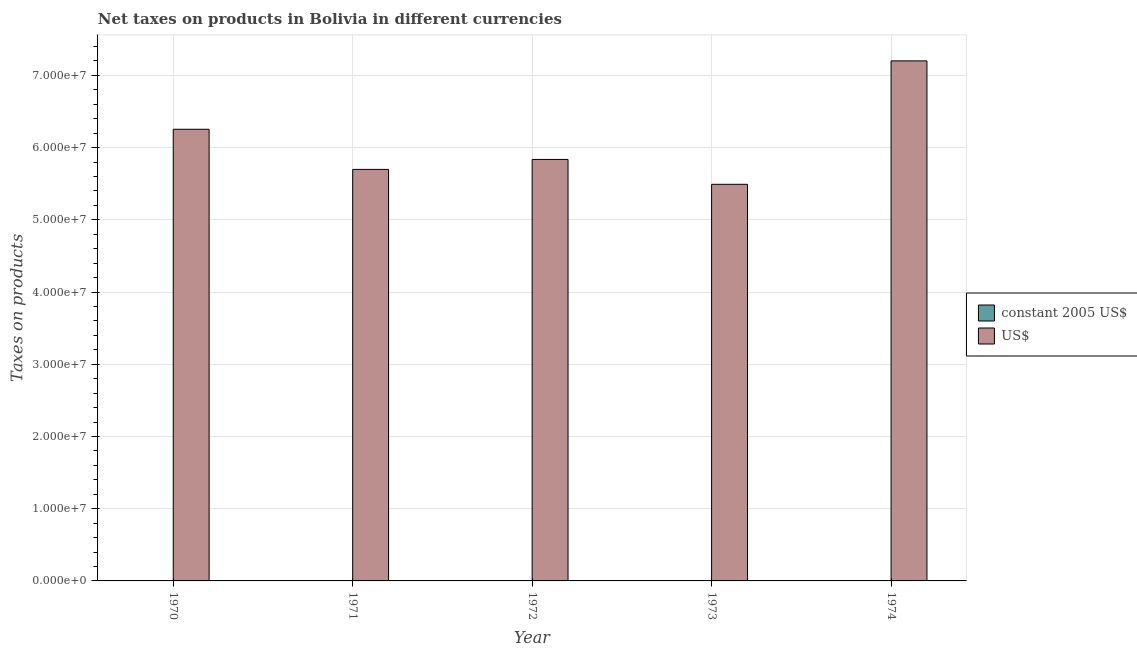How many different coloured bars are there?
Provide a succinct answer. 2. Are the number of bars on each tick of the X-axis equal?
Provide a succinct answer. Yes. What is the net taxes in constant 2005 us$ in 1974?
Offer a very short reply. 1441. Across all years, what is the maximum net taxes in constant 2005 us$?
Give a very brief answer. 1441. Across all years, what is the minimum net taxes in us$?
Offer a very short reply. 5.49e+07. In which year was the net taxes in constant 2005 us$ maximum?
Provide a short and direct response. 1974. In which year was the net taxes in us$ minimum?
Give a very brief answer. 1973. What is the total net taxes in constant 2005 us$ in the graph?
Make the answer very short. 4736. What is the difference between the net taxes in constant 2005 us$ in 1971 and that in 1972?
Provide a short and direct response. -99. What is the difference between the net taxes in us$ in 1971 and the net taxes in constant 2005 us$ in 1972?
Offer a very short reply. -1.38e+06. What is the average net taxes in us$ per year?
Keep it short and to the point. 6.10e+07. In how many years, is the net taxes in constant 2005 us$ greater than 12000000 units?
Your answer should be very brief. 0. What is the ratio of the net taxes in constant 2005 us$ in 1973 to that in 1974?
Ensure brevity in your answer.  0.76. Is the difference between the net taxes in constant 2005 us$ in 1970 and 1973 greater than the difference between the net taxes in us$ in 1970 and 1973?
Provide a succinct answer. No. What is the difference between the highest and the second highest net taxes in us$?
Provide a succinct answer. 9.47e+06. What is the difference between the highest and the lowest net taxes in us$?
Provide a short and direct response. 1.71e+07. In how many years, is the net taxes in us$ greater than the average net taxes in us$ taken over all years?
Keep it short and to the point. 2. Is the sum of the net taxes in constant 2005 us$ in 1973 and 1974 greater than the maximum net taxes in us$ across all years?
Offer a terse response. Yes. What does the 2nd bar from the left in 1971 represents?
Make the answer very short. US$. What does the 1st bar from the right in 1974 represents?
Provide a short and direct response. US$. How many bars are there?
Make the answer very short. 10. How many years are there in the graph?
Offer a very short reply. 5. What is the difference between two consecutive major ticks on the Y-axis?
Provide a short and direct response. 1.00e+07. Does the graph contain any zero values?
Provide a short and direct response. No. Does the graph contain grids?
Your response must be concise. Yes. Where does the legend appear in the graph?
Give a very brief answer. Center right. What is the title of the graph?
Your response must be concise. Net taxes on products in Bolivia in different currencies. Does "US$" appear as one of the legend labels in the graph?
Offer a terse response. Yes. What is the label or title of the Y-axis?
Keep it short and to the point. Taxes on products. What is the Taxes on products in constant 2005 US$ in 1970?
Your answer should be very brief. 743. What is the Taxes on products in US$ in 1970?
Make the answer very short. 6.25e+07. What is the Taxes on products of constant 2005 US$ in 1971?
Your answer should be compact. 677. What is the Taxes on products in US$ in 1971?
Provide a succinct answer. 5.70e+07. What is the Taxes on products of constant 2005 US$ in 1972?
Ensure brevity in your answer.  776. What is the Taxes on products of US$ in 1972?
Ensure brevity in your answer.  5.84e+07. What is the Taxes on products in constant 2005 US$ in 1973?
Give a very brief answer. 1099. What is the Taxes on products in US$ in 1973?
Your answer should be compact. 5.49e+07. What is the Taxes on products in constant 2005 US$ in 1974?
Provide a succinct answer. 1441. What is the Taxes on products of US$ in 1974?
Your response must be concise. 7.20e+07. Across all years, what is the maximum Taxes on products of constant 2005 US$?
Keep it short and to the point. 1441. Across all years, what is the maximum Taxes on products in US$?
Provide a succinct answer. 7.20e+07. Across all years, what is the minimum Taxes on products of constant 2005 US$?
Provide a short and direct response. 677. Across all years, what is the minimum Taxes on products in US$?
Provide a succinct answer. 5.49e+07. What is the total Taxes on products of constant 2005 US$ in the graph?
Keep it short and to the point. 4736. What is the total Taxes on products in US$ in the graph?
Ensure brevity in your answer.  3.05e+08. What is the difference between the Taxes on products in US$ in 1970 and that in 1971?
Ensure brevity in your answer.  5.56e+06. What is the difference between the Taxes on products in constant 2005 US$ in 1970 and that in 1972?
Offer a terse response. -33. What is the difference between the Taxes on products in US$ in 1970 and that in 1972?
Make the answer very short. 4.17e+06. What is the difference between the Taxes on products in constant 2005 US$ in 1970 and that in 1973?
Offer a terse response. -356. What is the difference between the Taxes on products in US$ in 1970 and that in 1973?
Your answer should be very brief. 7.62e+06. What is the difference between the Taxes on products of constant 2005 US$ in 1970 and that in 1974?
Offer a terse response. -698. What is the difference between the Taxes on products in US$ in 1970 and that in 1974?
Give a very brief answer. -9.47e+06. What is the difference between the Taxes on products in constant 2005 US$ in 1971 and that in 1972?
Your response must be concise. -99. What is the difference between the Taxes on products of US$ in 1971 and that in 1972?
Make the answer very short. -1.38e+06. What is the difference between the Taxes on products of constant 2005 US$ in 1971 and that in 1973?
Keep it short and to the point. -422. What is the difference between the Taxes on products of US$ in 1971 and that in 1973?
Your answer should be very brief. 2.06e+06. What is the difference between the Taxes on products of constant 2005 US$ in 1971 and that in 1974?
Offer a terse response. -764. What is the difference between the Taxes on products in US$ in 1971 and that in 1974?
Give a very brief answer. -1.50e+07. What is the difference between the Taxes on products of constant 2005 US$ in 1972 and that in 1973?
Keep it short and to the point. -323. What is the difference between the Taxes on products of US$ in 1972 and that in 1973?
Give a very brief answer. 3.45e+06. What is the difference between the Taxes on products of constant 2005 US$ in 1972 and that in 1974?
Keep it short and to the point. -665. What is the difference between the Taxes on products in US$ in 1972 and that in 1974?
Make the answer very short. -1.36e+07. What is the difference between the Taxes on products of constant 2005 US$ in 1973 and that in 1974?
Give a very brief answer. -342. What is the difference between the Taxes on products of US$ in 1973 and that in 1974?
Make the answer very short. -1.71e+07. What is the difference between the Taxes on products in constant 2005 US$ in 1970 and the Taxes on products in US$ in 1971?
Keep it short and to the point. -5.70e+07. What is the difference between the Taxes on products in constant 2005 US$ in 1970 and the Taxes on products in US$ in 1972?
Your response must be concise. -5.84e+07. What is the difference between the Taxes on products in constant 2005 US$ in 1970 and the Taxes on products in US$ in 1973?
Ensure brevity in your answer.  -5.49e+07. What is the difference between the Taxes on products in constant 2005 US$ in 1970 and the Taxes on products in US$ in 1974?
Provide a short and direct response. -7.20e+07. What is the difference between the Taxes on products in constant 2005 US$ in 1971 and the Taxes on products in US$ in 1972?
Keep it short and to the point. -5.84e+07. What is the difference between the Taxes on products of constant 2005 US$ in 1971 and the Taxes on products of US$ in 1973?
Keep it short and to the point. -5.49e+07. What is the difference between the Taxes on products in constant 2005 US$ in 1971 and the Taxes on products in US$ in 1974?
Provide a short and direct response. -7.20e+07. What is the difference between the Taxes on products of constant 2005 US$ in 1972 and the Taxes on products of US$ in 1973?
Provide a succinct answer. -5.49e+07. What is the difference between the Taxes on products of constant 2005 US$ in 1972 and the Taxes on products of US$ in 1974?
Your answer should be compact. -7.20e+07. What is the difference between the Taxes on products of constant 2005 US$ in 1973 and the Taxes on products of US$ in 1974?
Your answer should be very brief. -7.20e+07. What is the average Taxes on products of constant 2005 US$ per year?
Ensure brevity in your answer.  947.2. What is the average Taxes on products of US$ per year?
Offer a terse response. 6.10e+07. In the year 1970, what is the difference between the Taxes on products in constant 2005 US$ and Taxes on products in US$?
Provide a succinct answer. -6.25e+07. In the year 1971, what is the difference between the Taxes on products of constant 2005 US$ and Taxes on products of US$?
Your response must be concise. -5.70e+07. In the year 1972, what is the difference between the Taxes on products in constant 2005 US$ and Taxes on products in US$?
Your answer should be compact. -5.84e+07. In the year 1973, what is the difference between the Taxes on products in constant 2005 US$ and Taxes on products in US$?
Your answer should be compact. -5.49e+07. In the year 1974, what is the difference between the Taxes on products of constant 2005 US$ and Taxes on products of US$?
Ensure brevity in your answer.  -7.20e+07. What is the ratio of the Taxes on products in constant 2005 US$ in 1970 to that in 1971?
Make the answer very short. 1.1. What is the ratio of the Taxes on products of US$ in 1970 to that in 1971?
Offer a terse response. 1.1. What is the ratio of the Taxes on products in constant 2005 US$ in 1970 to that in 1972?
Offer a terse response. 0.96. What is the ratio of the Taxes on products in US$ in 1970 to that in 1972?
Your answer should be compact. 1.07. What is the ratio of the Taxes on products in constant 2005 US$ in 1970 to that in 1973?
Give a very brief answer. 0.68. What is the ratio of the Taxes on products in US$ in 1970 to that in 1973?
Offer a terse response. 1.14. What is the ratio of the Taxes on products of constant 2005 US$ in 1970 to that in 1974?
Your answer should be compact. 0.52. What is the ratio of the Taxes on products of US$ in 1970 to that in 1974?
Give a very brief answer. 0.87. What is the ratio of the Taxes on products of constant 2005 US$ in 1971 to that in 1972?
Give a very brief answer. 0.87. What is the ratio of the Taxes on products in US$ in 1971 to that in 1972?
Your answer should be very brief. 0.98. What is the ratio of the Taxes on products in constant 2005 US$ in 1971 to that in 1973?
Your response must be concise. 0.62. What is the ratio of the Taxes on products in US$ in 1971 to that in 1973?
Ensure brevity in your answer.  1.04. What is the ratio of the Taxes on products in constant 2005 US$ in 1971 to that in 1974?
Keep it short and to the point. 0.47. What is the ratio of the Taxes on products in US$ in 1971 to that in 1974?
Ensure brevity in your answer.  0.79. What is the ratio of the Taxes on products of constant 2005 US$ in 1972 to that in 1973?
Offer a very short reply. 0.71. What is the ratio of the Taxes on products in US$ in 1972 to that in 1973?
Your answer should be very brief. 1.06. What is the ratio of the Taxes on products of constant 2005 US$ in 1972 to that in 1974?
Your answer should be compact. 0.54. What is the ratio of the Taxes on products of US$ in 1972 to that in 1974?
Your answer should be compact. 0.81. What is the ratio of the Taxes on products of constant 2005 US$ in 1973 to that in 1974?
Your answer should be compact. 0.76. What is the ratio of the Taxes on products in US$ in 1973 to that in 1974?
Your answer should be very brief. 0.76. What is the difference between the highest and the second highest Taxes on products of constant 2005 US$?
Offer a terse response. 342. What is the difference between the highest and the second highest Taxes on products in US$?
Your answer should be very brief. 9.47e+06. What is the difference between the highest and the lowest Taxes on products of constant 2005 US$?
Keep it short and to the point. 764. What is the difference between the highest and the lowest Taxes on products of US$?
Your answer should be compact. 1.71e+07. 